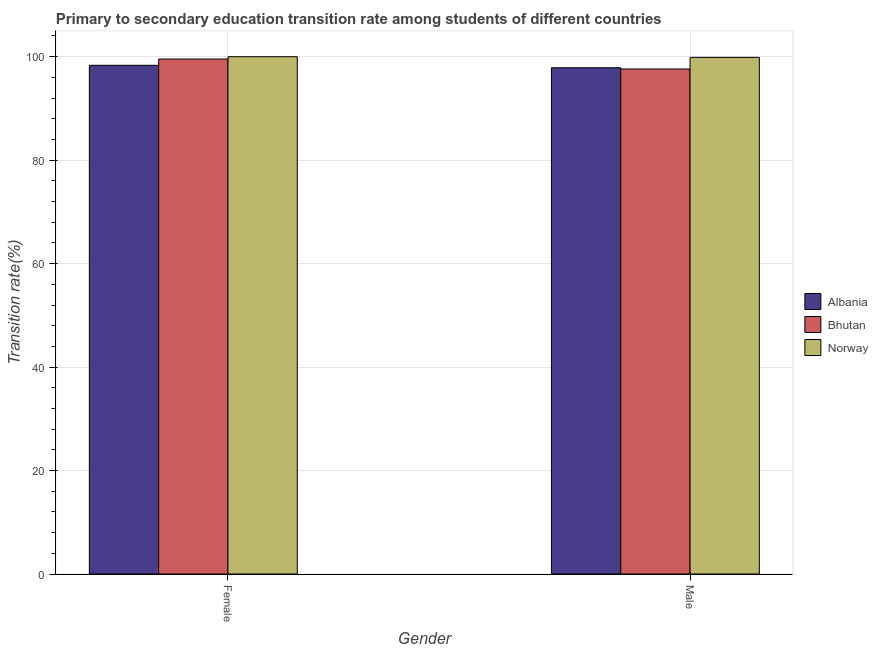How many groups of bars are there?
Provide a short and direct response. 2. Are the number of bars on each tick of the X-axis equal?
Offer a very short reply. Yes. How many bars are there on the 2nd tick from the left?
Give a very brief answer. 3. What is the transition rate among female students in Norway?
Provide a short and direct response. 100. Across all countries, what is the minimum transition rate among male students?
Offer a terse response. 97.62. In which country was the transition rate among female students minimum?
Your answer should be compact. Albania. What is the total transition rate among male students in the graph?
Your response must be concise. 295.35. What is the difference between the transition rate among female students in Albania and that in Bhutan?
Provide a succinct answer. -1.21. What is the difference between the transition rate among female students in Bhutan and the transition rate among male students in Norway?
Offer a terse response. -0.32. What is the average transition rate among female students per country?
Make the answer very short. 99.29. What is the difference between the transition rate among female students and transition rate among male students in Norway?
Ensure brevity in your answer.  0.13. What is the ratio of the transition rate among male students in Bhutan to that in Norway?
Your answer should be very brief. 0.98. In how many countries, is the transition rate among female students greater than the average transition rate among female students taken over all countries?
Your answer should be very brief. 2. What does the 2nd bar from the left in Male represents?
Provide a short and direct response. Bhutan. What does the 1st bar from the right in Male represents?
Ensure brevity in your answer.  Norway. How many bars are there?
Ensure brevity in your answer.  6. How many countries are there in the graph?
Your answer should be very brief. 3. Are the values on the major ticks of Y-axis written in scientific E-notation?
Keep it short and to the point. No. Does the graph contain grids?
Your answer should be compact. Yes. How many legend labels are there?
Keep it short and to the point. 3. What is the title of the graph?
Provide a short and direct response. Primary to secondary education transition rate among students of different countries. Does "East Asia (developing only)" appear as one of the legend labels in the graph?
Your answer should be very brief. No. What is the label or title of the Y-axis?
Provide a succinct answer. Transition rate(%). What is the Transition rate(%) of Albania in Female?
Your answer should be compact. 98.33. What is the Transition rate(%) of Bhutan in Female?
Keep it short and to the point. 99.55. What is the Transition rate(%) in Norway in Female?
Provide a succinct answer. 100. What is the Transition rate(%) of Albania in Male?
Make the answer very short. 97.86. What is the Transition rate(%) of Bhutan in Male?
Offer a terse response. 97.62. What is the Transition rate(%) in Norway in Male?
Keep it short and to the point. 99.87. Across all Gender, what is the maximum Transition rate(%) of Albania?
Your response must be concise. 98.33. Across all Gender, what is the maximum Transition rate(%) in Bhutan?
Your response must be concise. 99.55. Across all Gender, what is the maximum Transition rate(%) of Norway?
Ensure brevity in your answer.  100. Across all Gender, what is the minimum Transition rate(%) in Albania?
Your answer should be compact. 97.86. Across all Gender, what is the minimum Transition rate(%) of Bhutan?
Offer a very short reply. 97.62. Across all Gender, what is the minimum Transition rate(%) of Norway?
Offer a terse response. 99.87. What is the total Transition rate(%) of Albania in the graph?
Keep it short and to the point. 196.2. What is the total Transition rate(%) of Bhutan in the graph?
Your answer should be very brief. 197.17. What is the total Transition rate(%) in Norway in the graph?
Offer a terse response. 199.87. What is the difference between the Transition rate(%) of Albania in Female and that in Male?
Give a very brief answer. 0.47. What is the difference between the Transition rate(%) in Bhutan in Female and that in Male?
Your answer should be very brief. 1.92. What is the difference between the Transition rate(%) in Norway in Female and that in Male?
Make the answer very short. 0.13. What is the difference between the Transition rate(%) of Albania in Female and the Transition rate(%) of Bhutan in Male?
Offer a terse response. 0.71. What is the difference between the Transition rate(%) in Albania in Female and the Transition rate(%) in Norway in Male?
Offer a very short reply. -1.53. What is the difference between the Transition rate(%) of Bhutan in Female and the Transition rate(%) of Norway in Male?
Offer a very short reply. -0.32. What is the average Transition rate(%) of Albania per Gender?
Your response must be concise. 98.1. What is the average Transition rate(%) of Bhutan per Gender?
Make the answer very short. 98.59. What is the average Transition rate(%) of Norway per Gender?
Make the answer very short. 99.93. What is the difference between the Transition rate(%) of Albania and Transition rate(%) of Bhutan in Female?
Offer a very short reply. -1.21. What is the difference between the Transition rate(%) of Albania and Transition rate(%) of Norway in Female?
Provide a short and direct response. -1.67. What is the difference between the Transition rate(%) in Bhutan and Transition rate(%) in Norway in Female?
Your answer should be compact. -0.45. What is the difference between the Transition rate(%) of Albania and Transition rate(%) of Bhutan in Male?
Your response must be concise. 0.24. What is the difference between the Transition rate(%) in Albania and Transition rate(%) in Norway in Male?
Make the answer very short. -2. What is the difference between the Transition rate(%) in Bhutan and Transition rate(%) in Norway in Male?
Offer a very short reply. -2.24. What is the ratio of the Transition rate(%) of Albania in Female to that in Male?
Your answer should be very brief. 1. What is the ratio of the Transition rate(%) of Bhutan in Female to that in Male?
Your response must be concise. 1.02. What is the difference between the highest and the second highest Transition rate(%) of Albania?
Your answer should be compact. 0.47. What is the difference between the highest and the second highest Transition rate(%) of Bhutan?
Offer a very short reply. 1.92. What is the difference between the highest and the second highest Transition rate(%) of Norway?
Offer a terse response. 0.13. What is the difference between the highest and the lowest Transition rate(%) of Albania?
Your answer should be very brief. 0.47. What is the difference between the highest and the lowest Transition rate(%) of Bhutan?
Provide a short and direct response. 1.92. What is the difference between the highest and the lowest Transition rate(%) in Norway?
Provide a short and direct response. 0.13. 